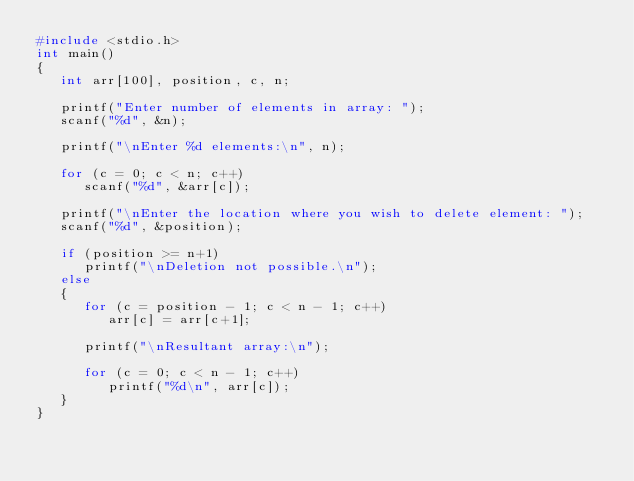Convert code to text. <code><loc_0><loc_0><loc_500><loc_500><_C_>#include <stdio.h> 
int main()
{
   int arr[100], position, c, n;
 
   printf("Enter number of elements in array: ");
   scanf("%d", &n);
 
   printf("\nEnter %d elements:\n", n);
 
   for (c = 0; c < n; c++)
      scanf("%d", &arr[c]);
 
   printf("\nEnter the location where you wish to delete element: ");
   scanf("%d", &position);
 
   if (position >= n+1)
      printf("\nDeletion not possible.\n");
   else
   {
      for (c = position - 1; c < n - 1; c++)
         arr[c] = arr[c+1];
 
      printf("\nResultant array:\n");
 
      for (c = 0; c < n - 1; c++)
         printf("%d\n", arr[c]);
   }
}
</code> 